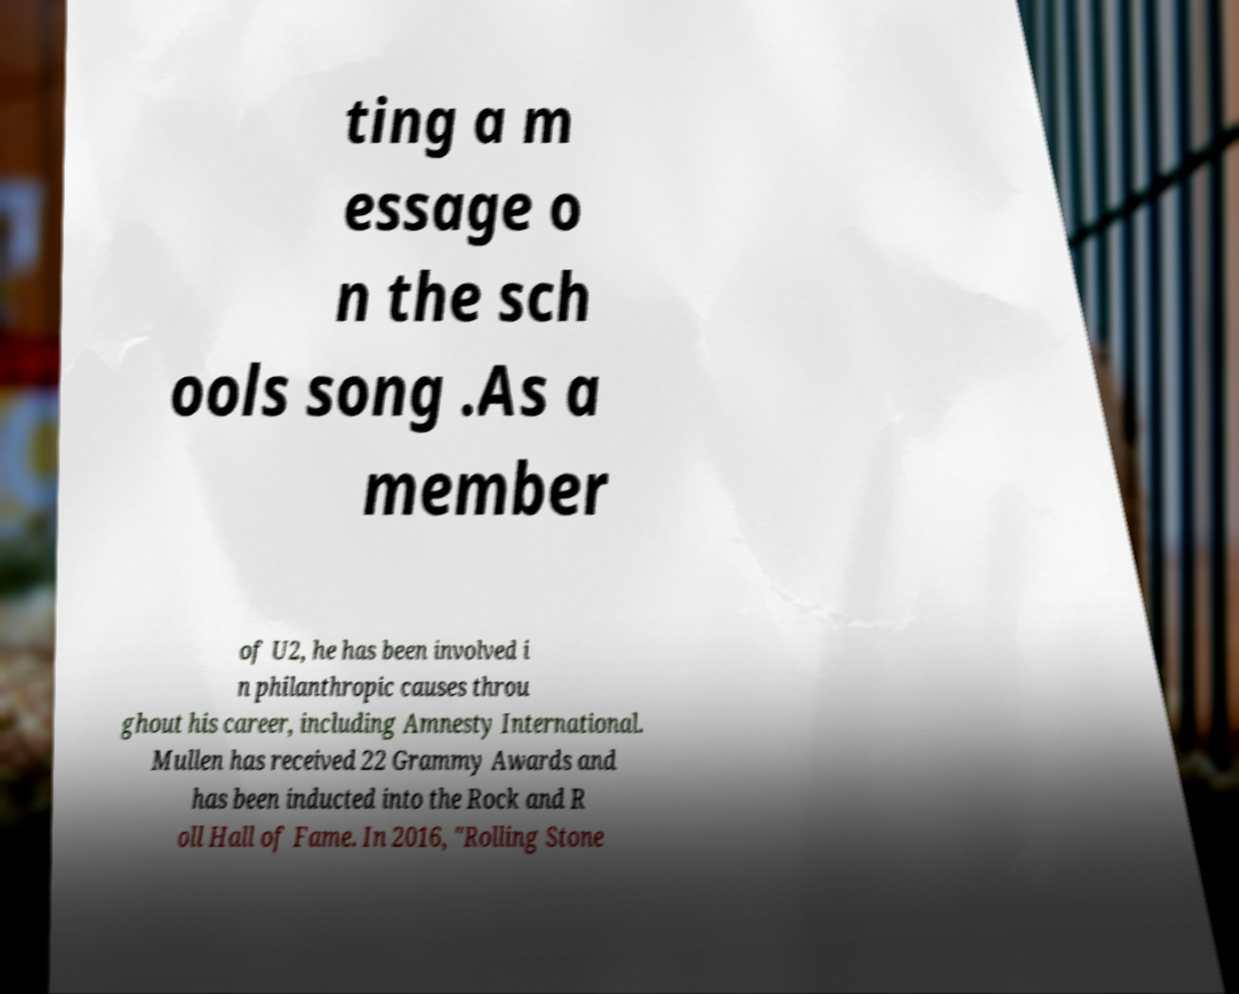Please identify and transcribe the text found in this image. ting a m essage o n the sch ools song .As a member of U2, he has been involved i n philanthropic causes throu ghout his career, including Amnesty International. Mullen has received 22 Grammy Awards and has been inducted into the Rock and R oll Hall of Fame. In 2016, "Rolling Stone 